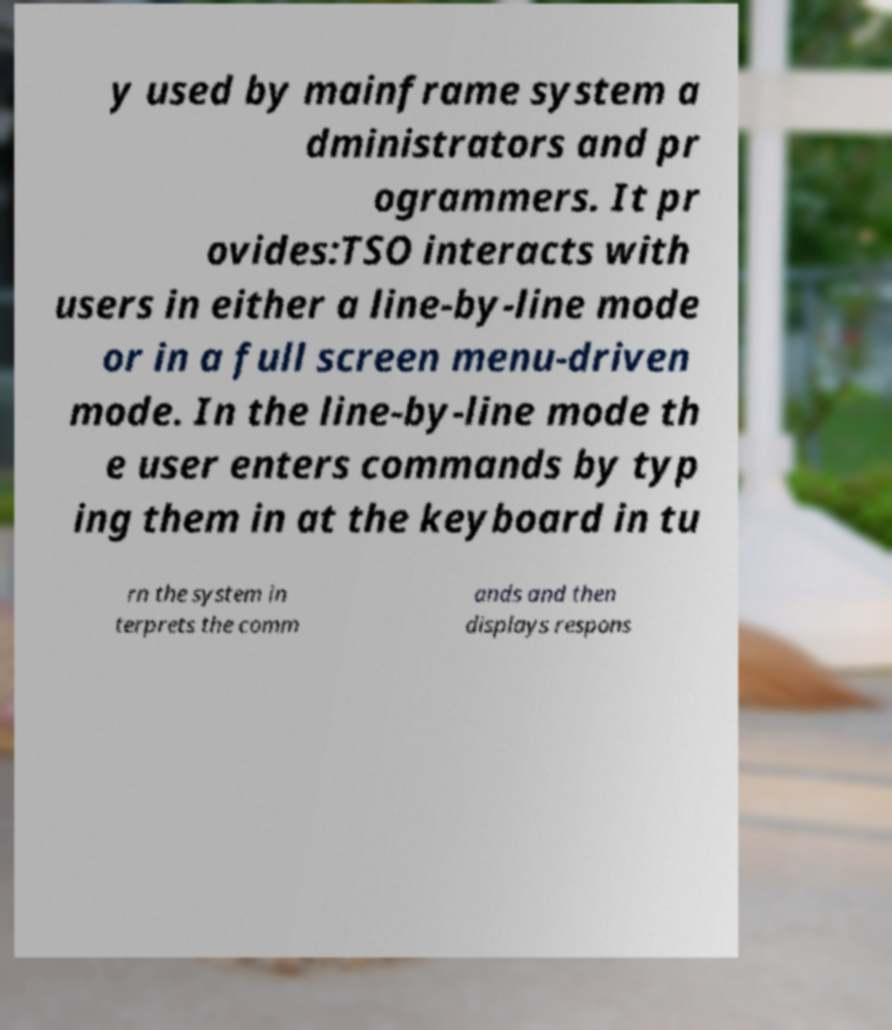Please identify and transcribe the text found in this image. y used by mainframe system a dministrators and pr ogrammers. It pr ovides:TSO interacts with users in either a line-by-line mode or in a full screen menu-driven mode. In the line-by-line mode th e user enters commands by typ ing them in at the keyboard in tu rn the system in terprets the comm ands and then displays respons 